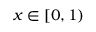<formula> <loc_0><loc_0><loc_500><loc_500>x \in [ 0 , 1 )</formula> 